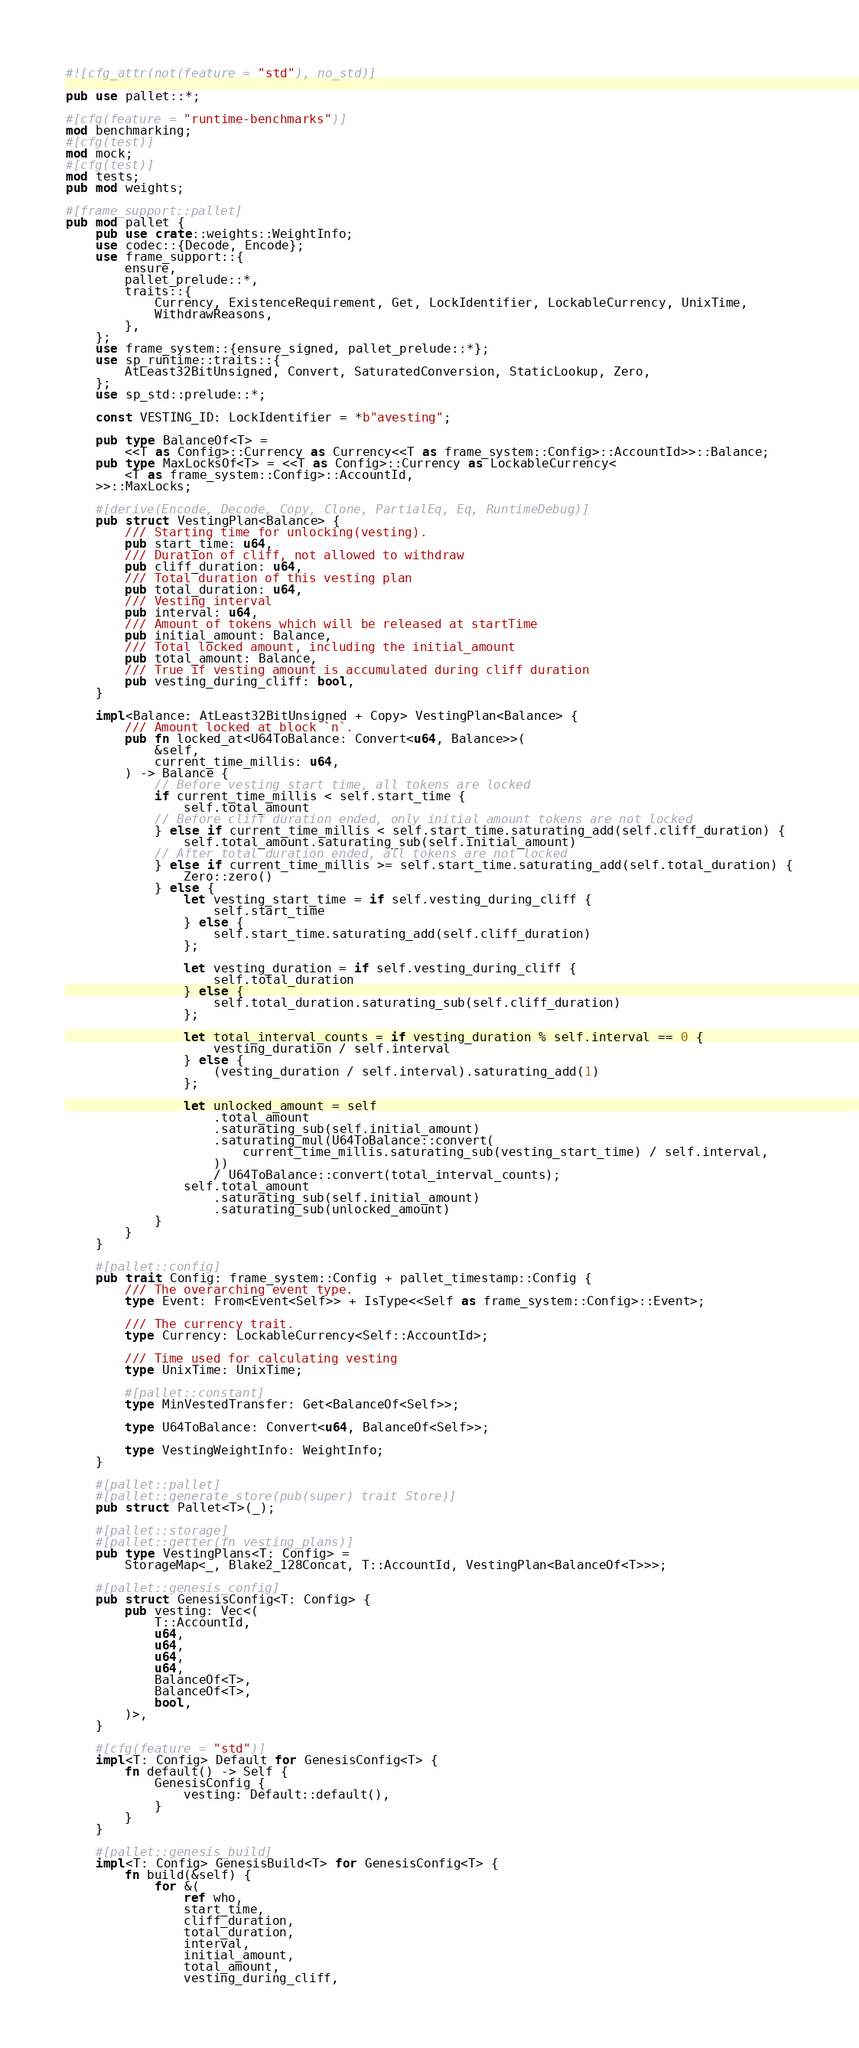Convert code to text. <code><loc_0><loc_0><loc_500><loc_500><_Rust_>#![cfg_attr(not(feature = "std"), no_std)]

pub use pallet::*;

#[cfg(feature = "runtime-benchmarks")]
mod benchmarking;
#[cfg(test)]
mod mock;
#[cfg(test)]
mod tests;
pub mod weights;

#[frame_support::pallet]
pub mod pallet {
    pub use crate::weights::WeightInfo;
    use codec::{Decode, Encode};
    use frame_support::{
        ensure,
        pallet_prelude::*,
        traits::{
            Currency, ExistenceRequirement, Get, LockIdentifier, LockableCurrency, UnixTime,
            WithdrawReasons,
        },
    };
    use frame_system::{ensure_signed, pallet_prelude::*};
    use sp_runtime::traits::{
        AtLeast32BitUnsigned, Convert, SaturatedConversion, StaticLookup, Zero,
    };
    use sp_std::prelude::*;

    const VESTING_ID: LockIdentifier = *b"avesting";

    pub type BalanceOf<T> =
        <<T as Config>::Currency as Currency<<T as frame_system::Config>::AccountId>>::Balance;
    pub type MaxLocksOf<T> = <<T as Config>::Currency as LockableCurrency<
        <T as frame_system::Config>::AccountId,
    >>::MaxLocks;

    #[derive(Encode, Decode, Copy, Clone, PartialEq, Eq, RuntimeDebug)]
    pub struct VestingPlan<Balance> {
        /// Starting time for unlocking(vesting).
        pub start_time: u64,
        /// Duration of cliff, not allowed to withdraw
        pub cliff_duration: u64,
        /// Total duration of this vesting plan
        pub total_duration: u64,
        /// Vesting interval
        pub interval: u64,
        /// Amount of tokens which will be released at startTime
        pub initial_amount: Balance,
        /// Total locked amount, including the initial_amount
        pub total_amount: Balance,
        /// True if vesting amount is accumulated during cliff duration
        pub vesting_during_cliff: bool,
    }

    impl<Balance: AtLeast32BitUnsigned + Copy> VestingPlan<Balance> {
        /// Amount locked at block `n`.
        pub fn locked_at<U64ToBalance: Convert<u64, Balance>>(
            &self,
            current_time_millis: u64,
        ) -> Balance {
            // Before vesting start time, all tokens are locked
            if current_time_millis < self.start_time {
                self.total_amount
            // Before cliff duration ended, only initial amount tokens are not locked
            } else if current_time_millis < self.start_time.saturating_add(self.cliff_duration) {
                self.total_amount.saturating_sub(self.initial_amount)
            // After total duration ended, all tokens are not locked
            } else if current_time_millis >= self.start_time.saturating_add(self.total_duration) {
                Zero::zero()
            } else {
                let vesting_start_time = if self.vesting_during_cliff {
                    self.start_time
                } else {
                    self.start_time.saturating_add(self.cliff_duration)
                };

                let vesting_duration = if self.vesting_during_cliff {
                    self.total_duration
                } else {
                    self.total_duration.saturating_sub(self.cliff_duration)
                };

                let total_interval_counts = if vesting_duration % self.interval == 0 {
                    vesting_duration / self.interval
                } else {
                    (vesting_duration / self.interval).saturating_add(1)
                };

                let unlocked_amount = self
                    .total_amount
                    .saturating_sub(self.initial_amount)
                    .saturating_mul(U64ToBalance::convert(
                        current_time_millis.saturating_sub(vesting_start_time) / self.interval,
                    ))
                    / U64ToBalance::convert(total_interval_counts);
                self.total_amount
                    .saturating_sub(self.initial_amount)
                    .saturating_sub(unlocked_amount)
            }
        }
    }

    #[pallet::config]
    pub trait Config: frame_system::Config + pallet_timestamp::Config {
        /// The overarching event type.
        type Event: From<Event<Self>> + IsType<<Self as frame_system::Config>::Event>;

        /// The currency trait.
        type Currency: LockableCurrency<Self::AccountId>;

        /// Time used for calculating vesting
        type UnixTime: UnixTime;

        #[pallet::constant]
        type MinVestedTransfer: Get<BalanceOf<Self>>;

        type U64ToBalance: Convert<u64, BalanceOf<Self>>;

        type VestingWeightInfo: WeightInfo;
    }

    #[pallet::pallet]
    #[pallet::generate_store(pub(super) trait Store)]
    pub struct Pallet<T>(_);

    #[pallet::storage]
    #[pallet::getter(fn vesting_plans)]
    pub type VestingPlans<T: Config> =
        StorageMap<_, Blake2_128Concat, T::AccountId, VestingPlan<BalanceOf<T>>>;

    #[pallet::genesis_config]
    pub struct GenesisConfig<T: Config> {
        pub vesting: Vec<(
            T::AccountId,
            u64,
            u64,
            u64,
            u64,
            BalanceOf<T>,
            BalanceOf<T>,
            bool,
        )>,
    }

    #[cfg(feature = "std")]
    impl<T: Config> Default for GenesisConfig<T> {
        fn default() -> Self {
            GenesisConfig {
                vesting: Default::default(),
            }
        }
    }

    #[pallet::genesis_build]
    impl<T: Config> GenesisBuild<T> for GenesisConfig<T> {
        fn build(&self) {
            for &(
                ref who,
                start_time,
                cliff_duration,
                total_duration,
                interval,
                initial_amount,
                total_amount,
                vesting_during_cliff,</code> 